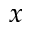<formula> <loc_0><loc_0><loc_500><loc_500>x</formula> 